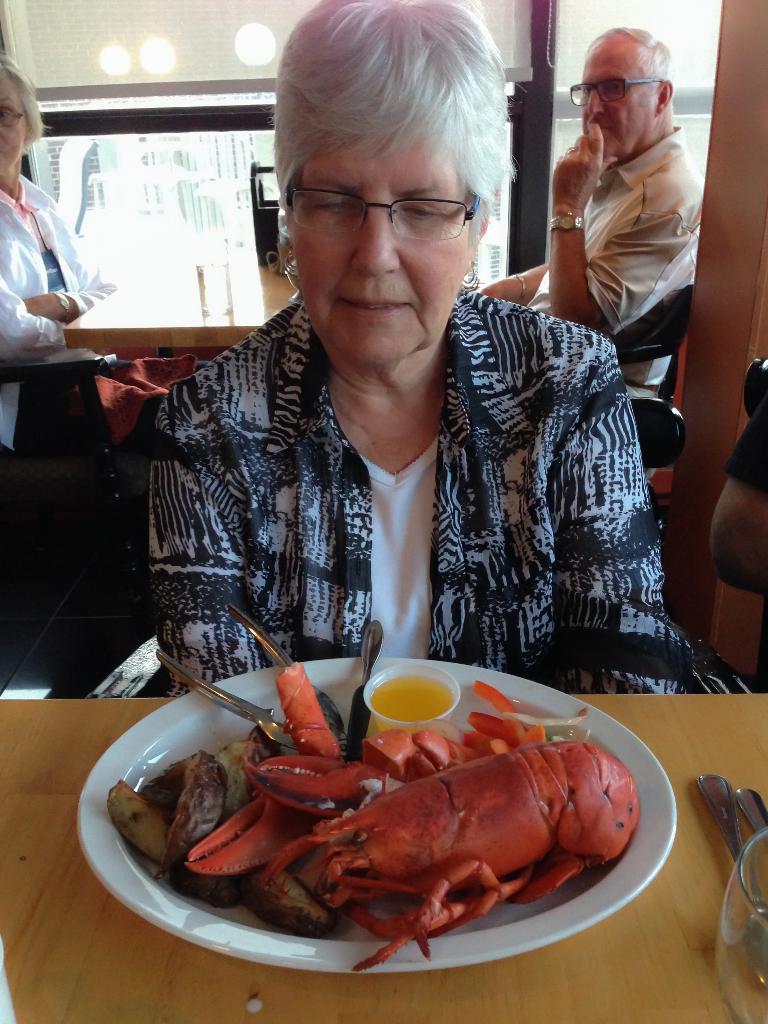Could you give a brief overview of what you see in this image? In this image we can see people sitting. At the bottom there is a table and we can see a glass, spoons and a plate containing food placed on the table. In the background there is a wall and we can see blinds. 